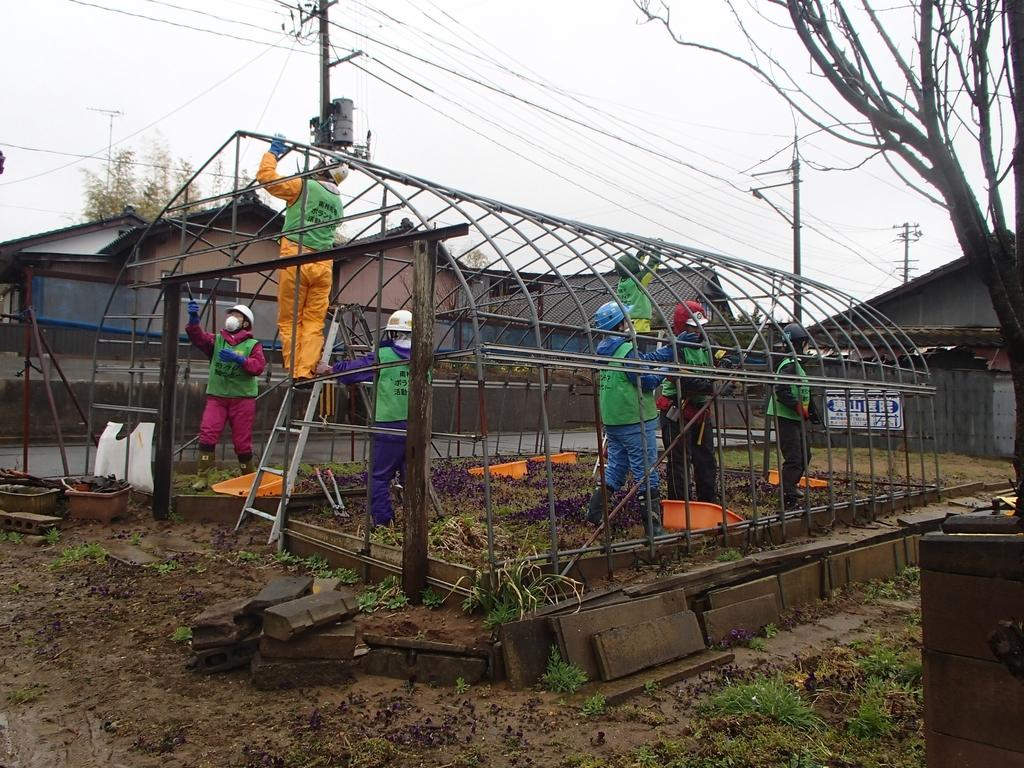What is the person in the image doing? The person is standing on a ladder. What is the person wearing? The person is wearing a yellow dress. What can be seen on the right side of the image? There are other people working on the right side of the image. What is visible at the top of the image? The sky is visible at the top of the image. What type of pets can be seen playing with a lamp in the image? There are no pets or lamps present in the image. Is there a drum visible in the image? There is no drum visible in the image. 